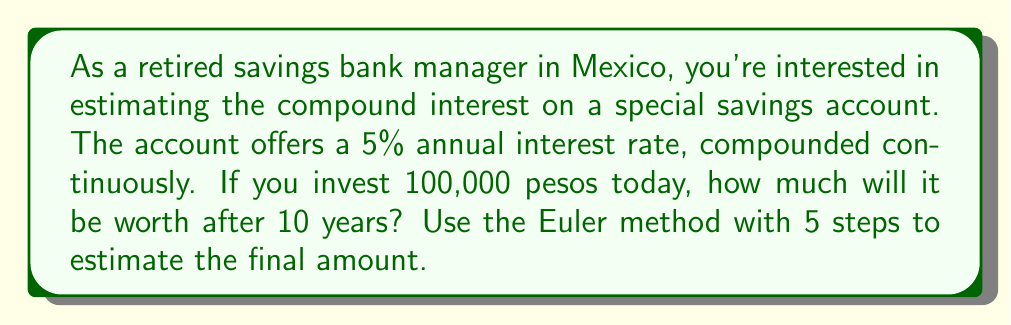Can you answer this question? Let's approach this step-by-step using the Euler method:

1) The continuous compound interest formula is:
   $$A(t) = P e^{rt}$$
   where $A(t)$ is the amount at time $t$, $P$ is the principal, $r$ is the interest rate, and $t$ is the time in years.

2) We can rewrite this as a differential equation:
   $$\frac{dA}{dt} = rA$$

3) For the Euler method, we use the formula:
   $$A_{n+1} = A_n + h \cdot f(t_n, A_n)$$
   where $h$ is the step size and $f(t_n, A_n) = rA_n$

4) Given:
   $P = 100,000$ pesos
   $r = 0.05$ (5% annual rate)
   $t = 10$ years
   Number of steps = 5
   Step size $h = \frac{10}{5} = 2$ years

5) Let's calculate step by step:

   Step 0: $A_0 = 100,000$
   Step 1: $A_1 = 100,000 + 2 \cdot (0.05 \cdot 100,000) = 110,000$
   Step 2: $A_2 = 110,000 + 2 \cdot (0.05 \cdot 110,000) = 121,000$
   Step 3: $A_3 = 121,000 + 2 \cdot (0.05 \cdot 121,000) = 133,100$
   Step 4: $A_4 = 133,100 + 2 \cdot (0.05 \cdot 133,100) = 146,410$
   Step 5: $A_5 = 146,410 + 2 \cdot (0.05 \cdot 146,410) = 161,051$

6) Therefore, the estimated amount after 10 years is 161,051 pesos.

Note: This is an estimate. The actual value using the exact formula would be:
$$A = 100,000 \cdot e^{0.05 \cdot 10} \approx 164,872$$ pesos.
The Euler method with just 5 steps gives a reasonable approximation.
Answer: 161,051 pesos 